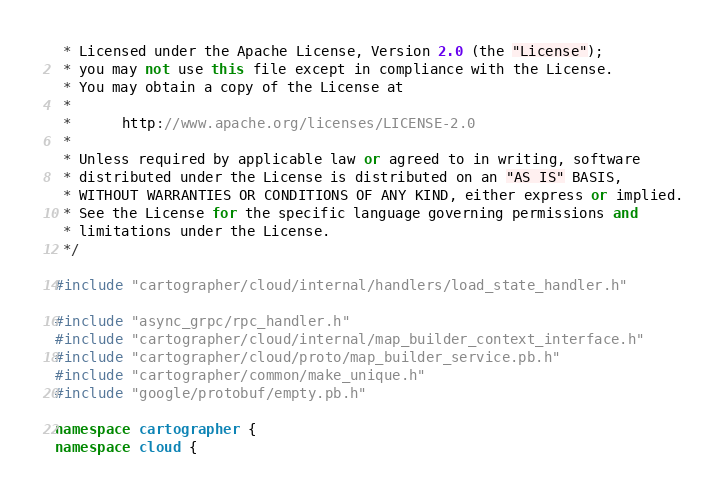Convert code to text. <code><loc_0><loc_0><loc_500><loc_500><_C++_> * Licensed under the Apache License, Version 2.0 (the "License");
 * you may not use this file except in compliance with the License.
 * You may obtain a copy of the License at
 *
 *      http://www.apache.org/licenses/LICENSE-2.0
 *
 * Unless required by applicable law or agreed to in writing, software
 * distributed under the License is distributed on an "AS IS" BASIS,
 * WITHOUT WARRANTIES OR CONDITIONS OF ANY KIND, either express or implied.
 * See the License for the specific language governing permissions and
 * limitations under the License.
 */

#include "cartographer/cloud/internal/handlers/load_state_handler.h"

#include "async_grpc/rpc_handler.h"
#include "cartographer/cloud/internal/map_builder_context_interface.h"
#include "cartographer/cloud/proto/map_builder_service.pb.h"
#include "cartographer/common/make_unique.h"
#include "google/protobuf/empty.pb.h"

namespace cartographer {
namespace cloud {</code> 